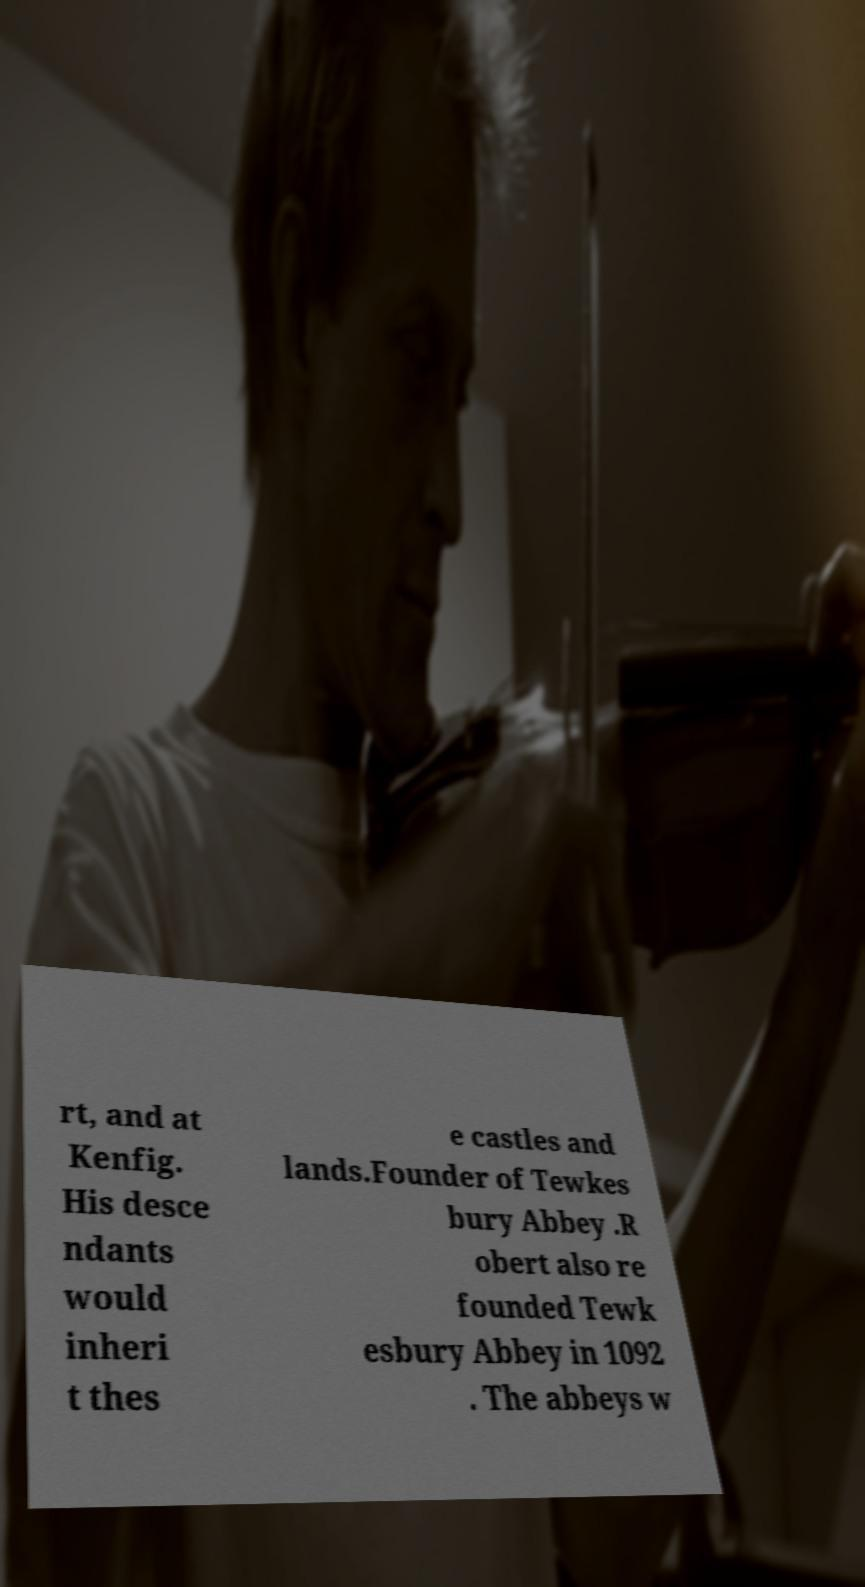Could you extract and type out the text from this image? rt, and at Kenfig. His desce ndants would inheri t thes e castles and lands.Founder of Tewkes bury Abbey .R obert also re founded Tewk esbury Abbey in 1092 . The abbeys w 